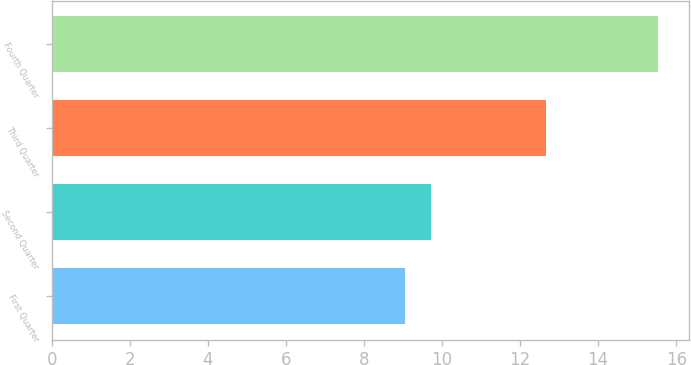Convert chart. <chart><loc_0><loc_0><loc_500><loc_500><bar_chart><fcel>First Quarter<fcel>Second Quarter<fcel>Third Quarter<fcel>Fourth Quarter<nl><fcel>9.06<fcel>9.71<fcel>12.66<fcel>15.54<nl></chart> 